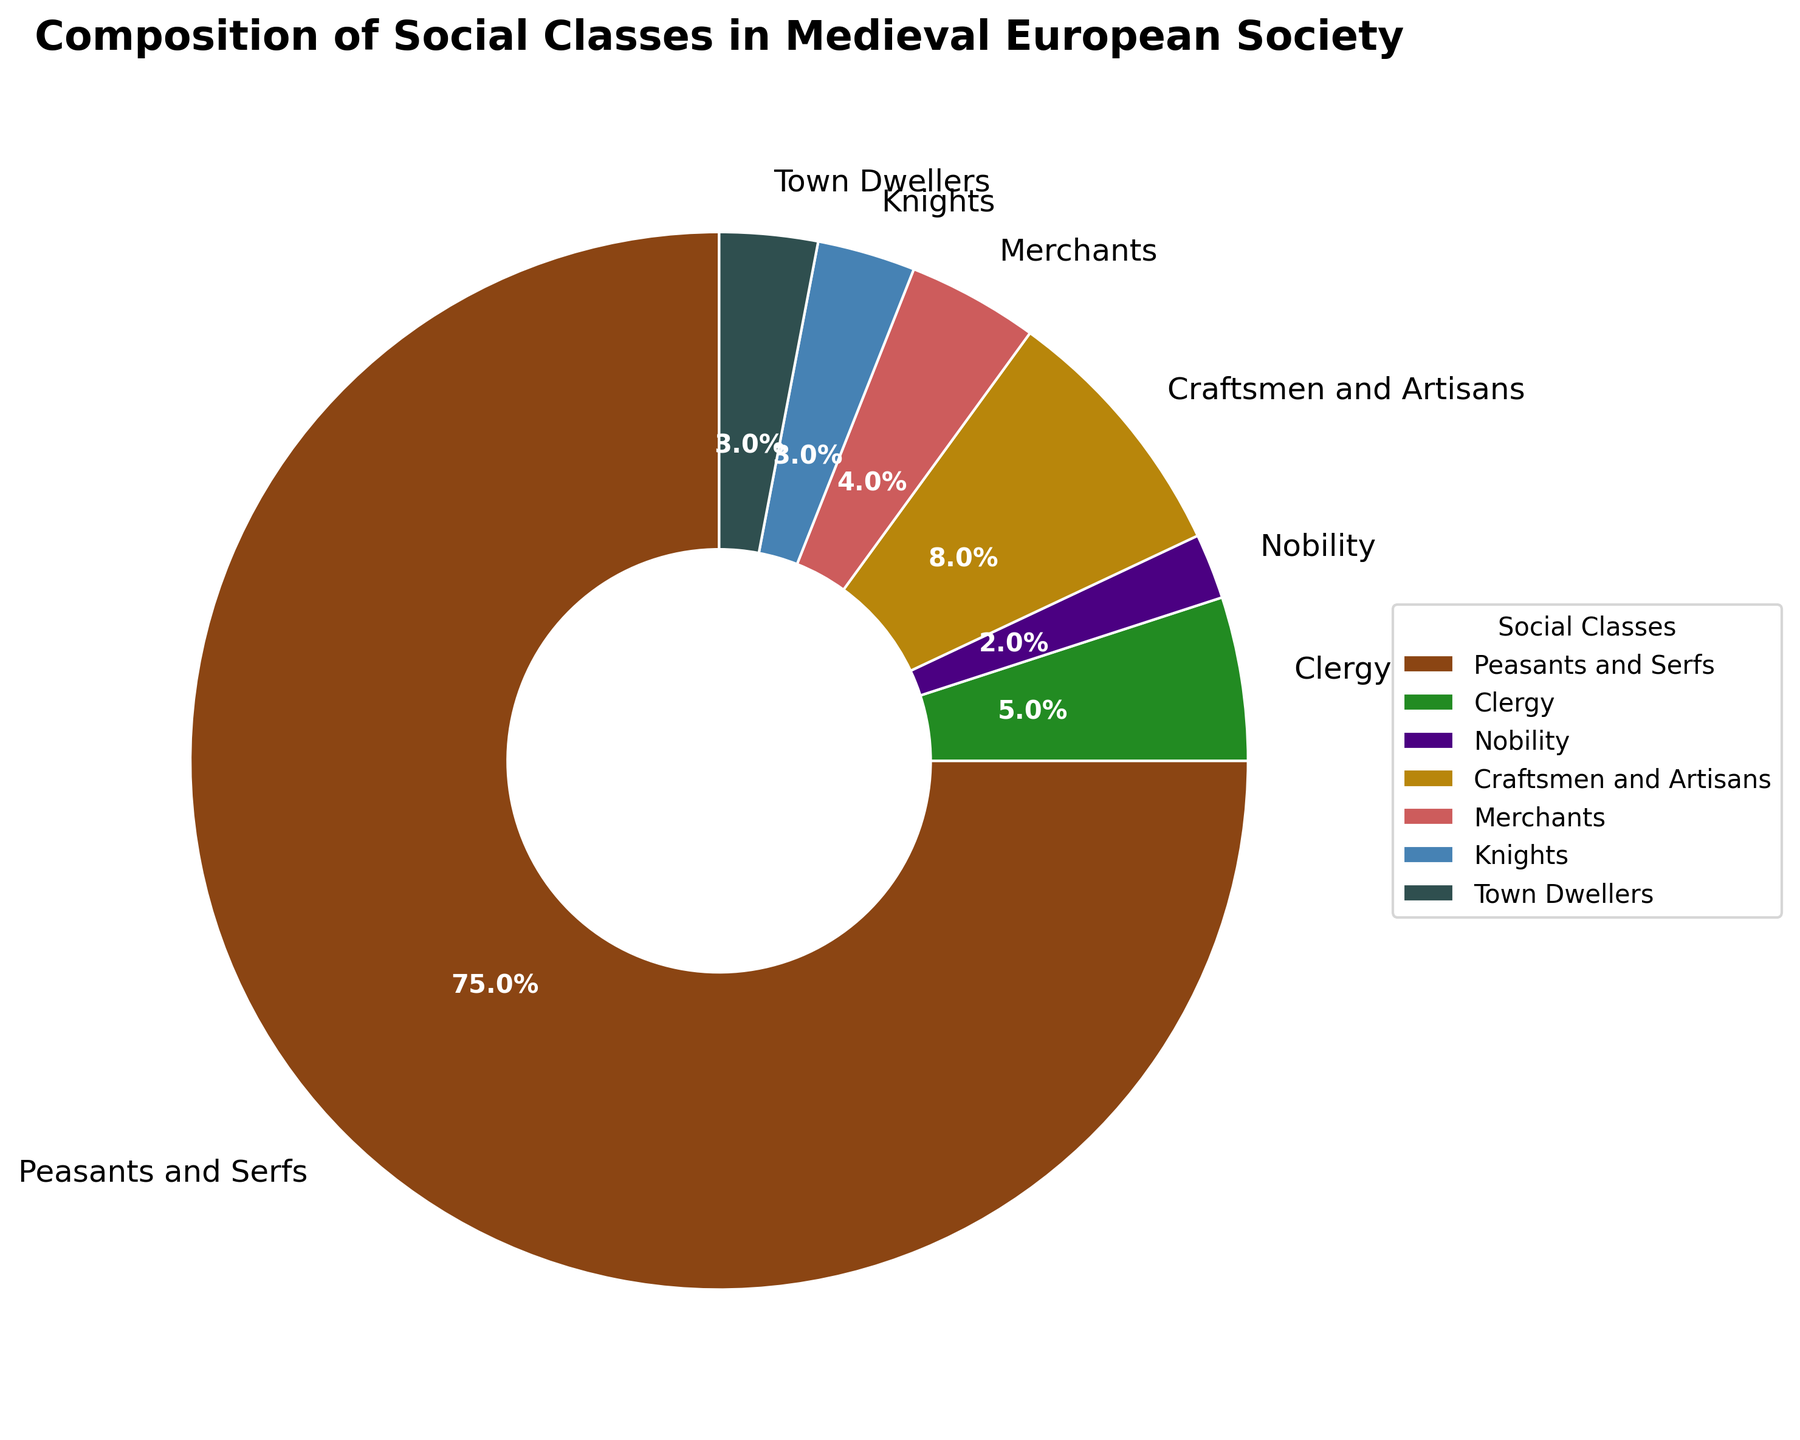What's the combined percentage of Merchants and Knights? From the figure, the percentage of Merchants is 4% and the percentage of Knights is 3%. Adding these two percentages together, we get 4% + 3% = 7%.
Answer: 7% Which social class has the smallest percentage, and what is that percentage? Observing the pie chart, only the Nobility has a percentage of 2%, which is the smallest among all social classes listed.
Answer: Nobility, 2% What is the difference in percentage between Craftsmen and Artisans and Clergy? From the pie chart, Craftsmen and Artisans represent 8% while the Clergy make up 5%. The difference between them is 8% - 5% = 3%.
Answer: 3% Which class occupies more percentage: Town Dwellers or Knights? By comparing both sections in the pie chart, Town Dwellers have 3% and Knights also have 3%. Therefore, they both occupy the same percentage.
Answer: Both are equal What percentage more do Peasants and Serfs compose compared to all other classes combined? From the chart, Peasants and Serfs represent 75%. Summing up all other classes' percentages (Clergy 5%, Nobility 2%, Craftsmen and Artisans 8%, Merchants 4%, Knights 3%, Town Dwellers 3%), we get 25%. Therefore, Peasants and Serfs are 75% - 25% = 50% more than all others combined.
Answer: 50% If the combined percentage of Clergy and Nobility is doubled, what would it be? First, find the combined percentage of Clergy (5%) and Nobility (2%) which is 5% + 2% = 7%. Doubling this gives 7% * 2 = 14%.
Answer: 14% Among Clergy, Merchants, and Town Dwellers, which class has the highest percentage and what is it? Observing the pie chart, Clergy has 5%, Merchants have 4%, and Town Dwellers have 3%. Therefore, Clergy has the highest percentage among the three at 5%.
Answer: Clergy, 5% 